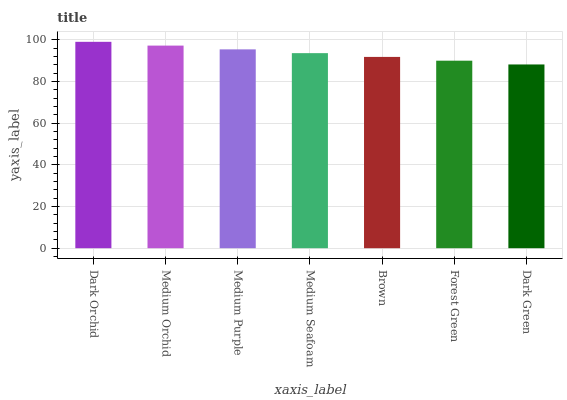Is Dark Green the minimum?
Answer yes or no. Yes. Is Dark Orchid the maximum?
Answer yes or no. Yes. Is Medium Orchid the minimum?
Answer yes or no. No. Is Medium Orchid the maximum?
Answer yes or no. No. Is Dark Orchid greater than Medium Orchid?
Answer yes or no. Yes. Is Medium Orchid less than Dark Orchid?
Answer yes or no. Yes. Is Medium Orchid greater than Dark Orchid?
Answer yes or no. No. Is Dark Orchid less than Medium Orchid?
Answer yes or no. No. Is Medium Seafoam the high median?
Answer yes or no. Yes. Is Medium Seafoam the low median?
Answer yes or no. Yes. Is Forest Green the high median?
Answer yes or no. No. Is Forest Green the low median?
Answer yes or no. No. 